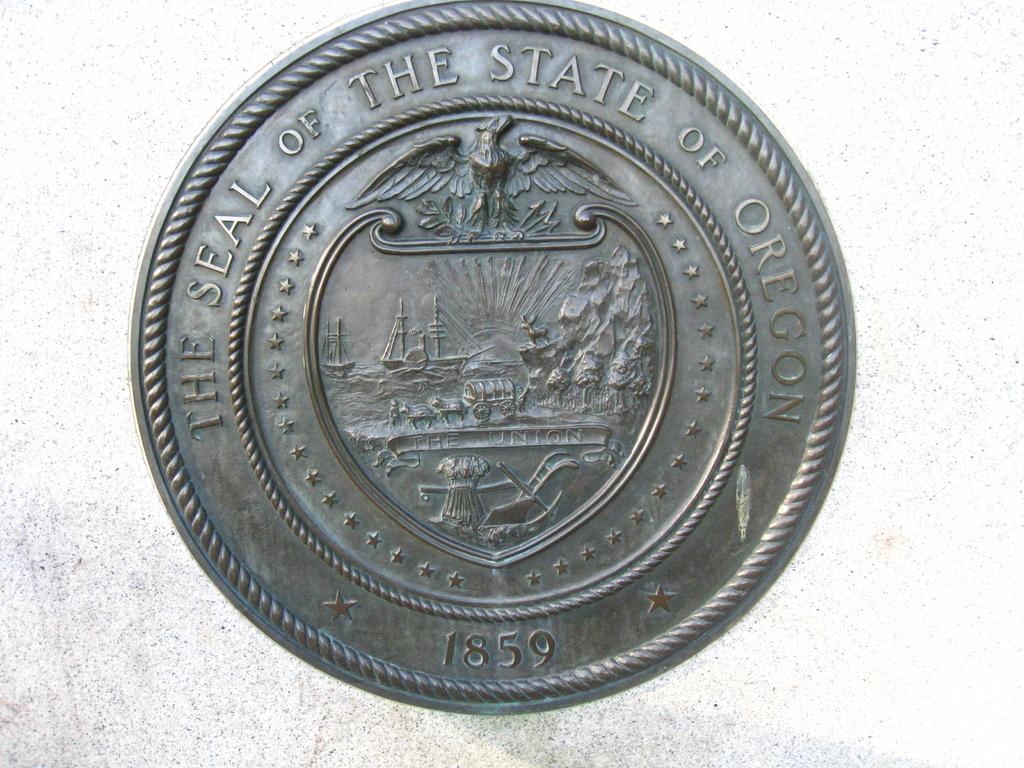What state is this coin from?
Provide a succinct answer. Oregon. What year was that coin made?
Ensure brevity in your answer.  1859. 